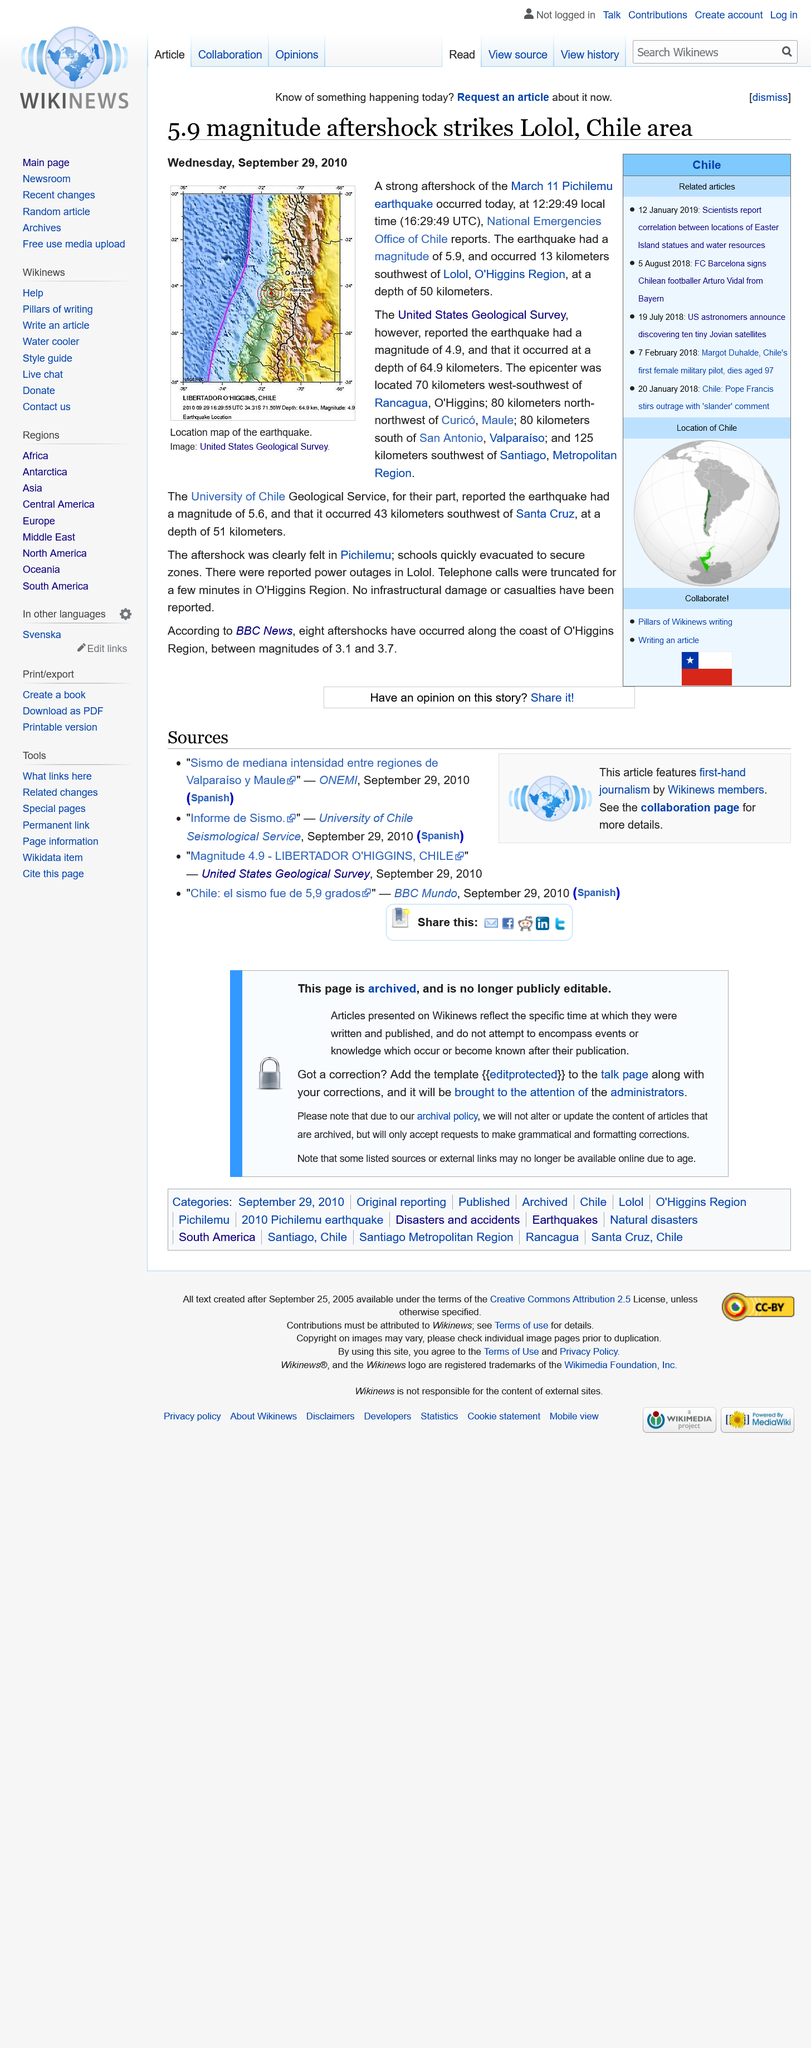List a handful of essential elements in this visual. The epicentre of the earthquake was located 70 kilometres away from Rancagua, O'Higgins, in the direction of San Fernando, Colchagua. The article titled "5.9 magnitude aftershock strikes Lolo, Chile area" was published on Wednesday, September 29, 2010. The aftershock had a magnitude of 5.9. 